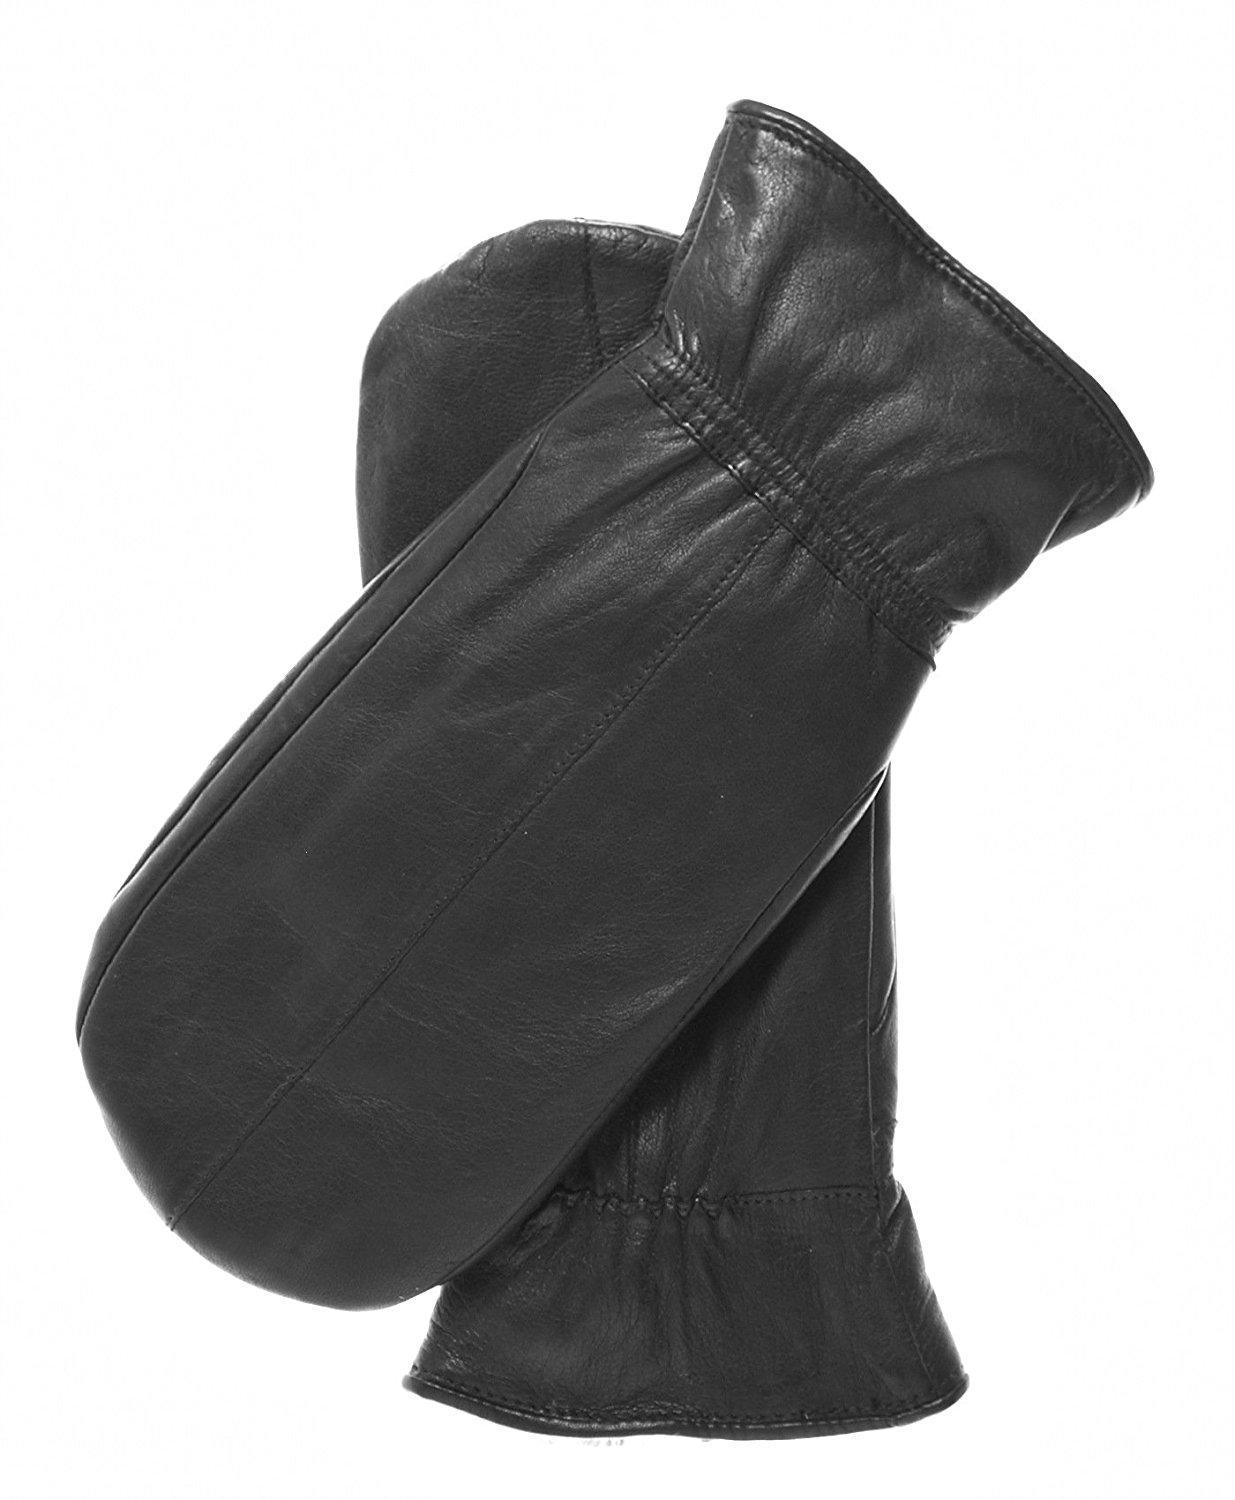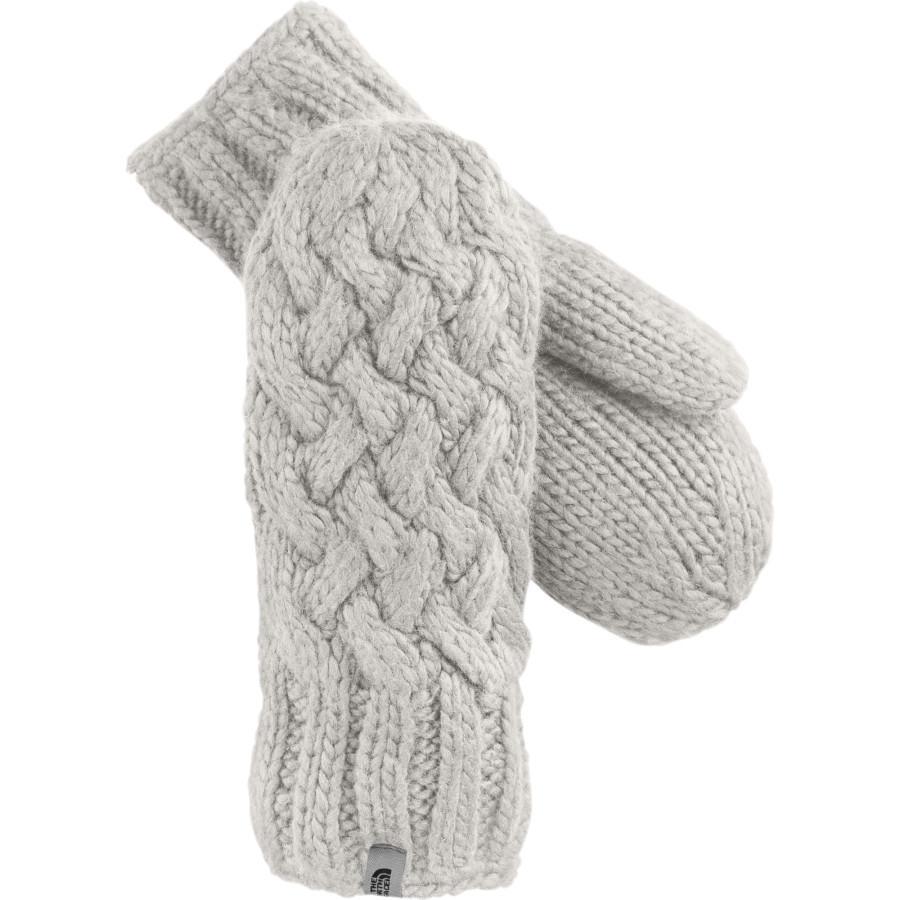The first image is the image on the left, the second image is the image on the right. Given the left and right images, does the statement "All mittens shown have rounded tops without fingers, and the knitted mitten pair on the left is a solid color with a diamond pattern." hold true? Answer yes or no. No. The first image is the image on the left, the second image is the image on the right. Given the left and right images, does the statement "One pair of gloves is dark grey." hold true? Answer yes or no. No. 